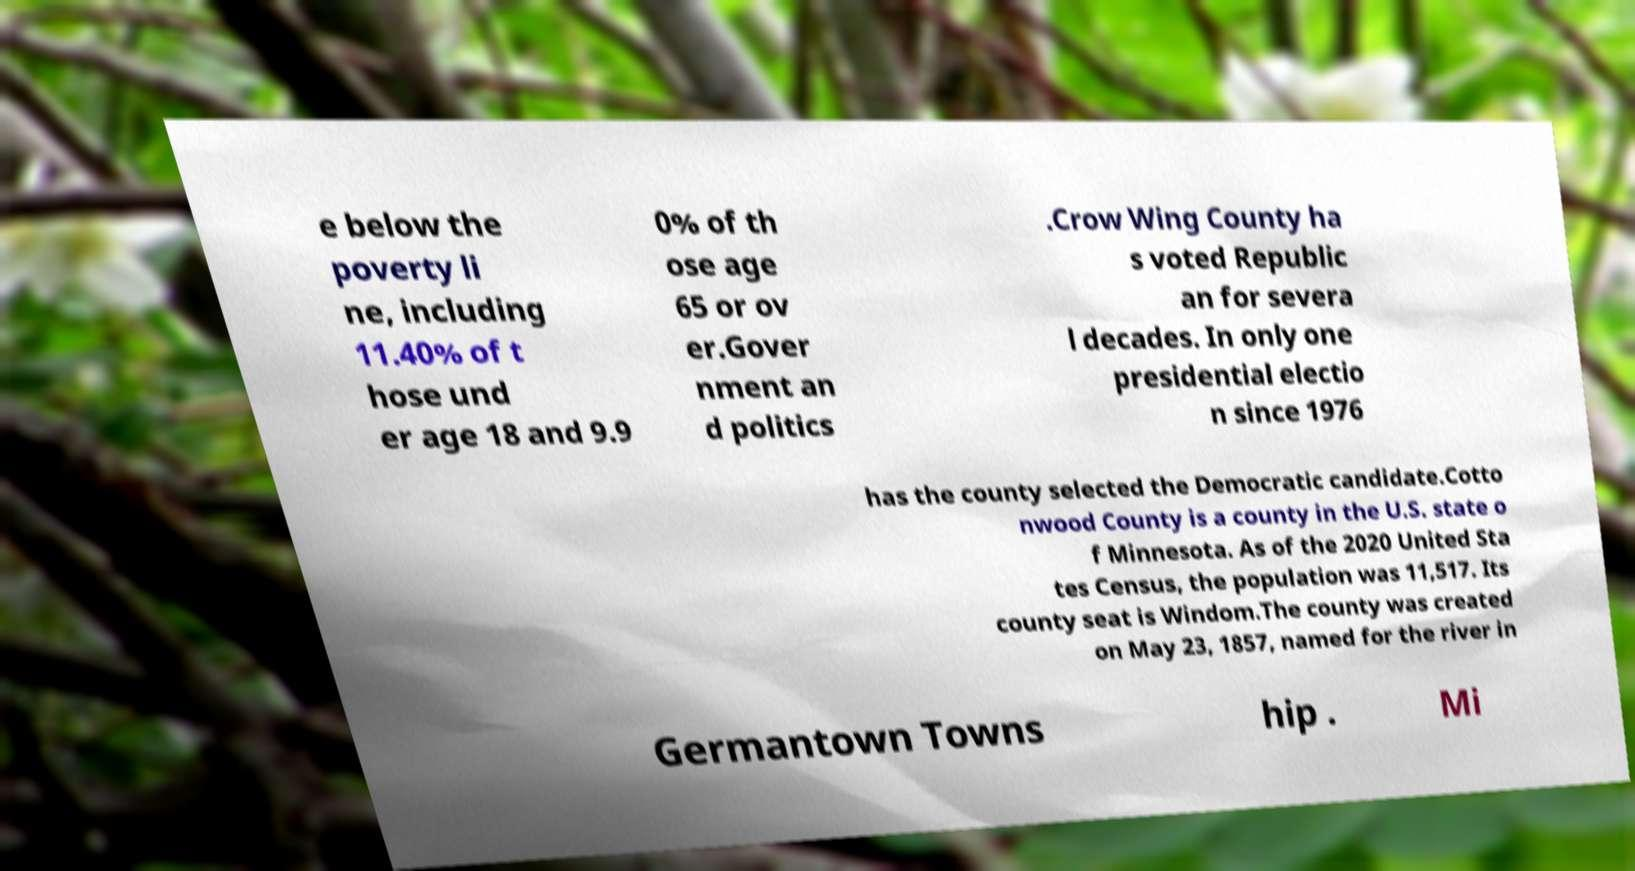Can you read and provide the text displayed in the image?This photo seems to have some interesting text. Can you extract and type it out for me? e below the poverty li ne, including 11.40% of t hose und er age 18 and 9.9 0% of th ose age 65 or ov er.Gover nment an d politics .Crow Wing County ha s voted Republic an for severa l decades. In only one presidential electio n since 1976 has the county selected the Democratic candidate.Cotto nwood County is a county in the U.S. state o f Minnesota. As of the 2020 United Sta tes Census, the population was 11,517. Its county seat is Windom.The county was created on May 23, 1857, named for the river in Germantown Towns hip . Mi 